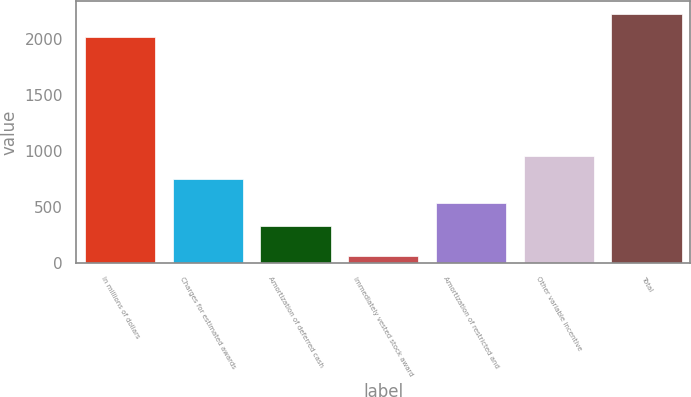Convert chart. <chart><loc_0><loc_0><loc_500><loc_500><bar_chart><fcel>In millions of dollars<fcel>Charges for estimated awards<fcel>Amortization of deferred cash<fcel>Immediately vested stock award<fcel>Amortization of restricted and<fcel>Other variable incentive<fcel>Total<nl><fcel>2015<fcel>745<fcel>325<fcel>61<fcel>535<fcel>955<fcel>2225<nl></chart> 